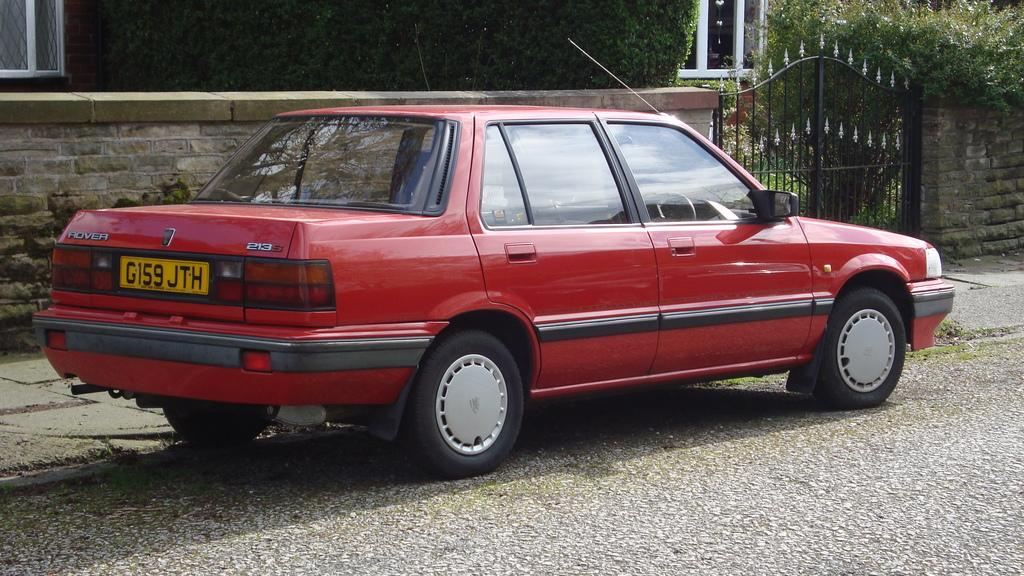What is the main feature of the image? There is a road in the image. What is located near the road? There is a car on the side of the road and a sidewalk near the car. What structures can be seen in the image? There are walls and a gate in the image. What can be seen in the background of the image? There are trees and a building with windows in the background. What word is being spelled out by the trees in the background? There is no word being spelled out by the trees in the background; they are simply trees. Is there a party happening in the image? There is no indication of a party in the image; it features a road, a car, a sidewalk, walls, a gate, trees, and a building with windows. 